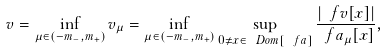Convert formula to latex. <formula><loc_0><loc_0><loc_500><loc_500>v = \inf _ { \mu \in ( - m _ { - } , m _ { + } ) } v _ { \mu } = \inf _ { \mu \in ( - m _ { - } , m _ { + } ) } \sup _ { 0 \ne x \in \ D o m [ \ f a ] } \frac { | \ f v [ x ] | } { \ f a _ { \mu } [ x ] } ,</formula> 